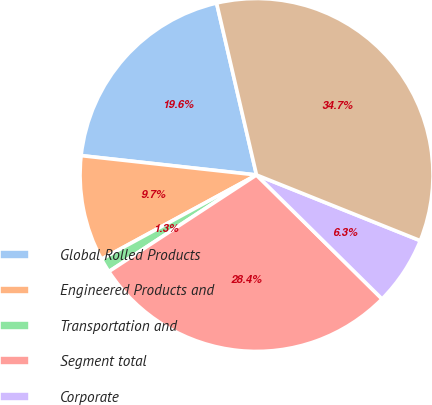Convert chart to OTSL. <chart><loc_0><loc_0><loc_500><loc_500><pie_chart><fcel>Global Rolled Products<fcel>Engineered Products and<fcel>Transportation and<fcel>Segment total<fcel>Corporate<fcel>Total restructuring and other<nl><fcel>19.62%<fcel>9.67%<fcel>1.3%<fcel>28.38%<fcel>6.33%<fcel>34.71%<nl></chart> 